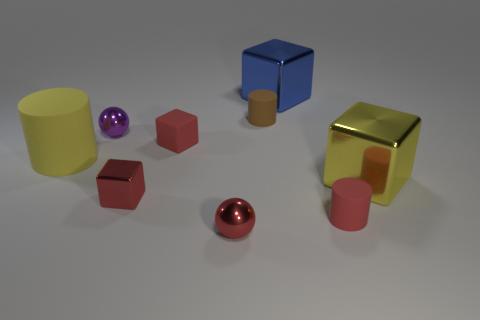Subtract 1 cubes. How many cubes are left? 3 Subtract all cyan cubes. Subtract all purple balls. How many cubes are left? 4 Add 1 tiny red metal cubes. How many objects exist? 10 Subtract all cubes. How many objects are left? 5 Subtract all spheres. Subtract all large blue shiny objects. How many objects are left? 6 Add 5 tiny cylinders. How many tiny cylinders are left? 7 Add 7 large yellow rubber cylinders. How many large yellow rubber cylinders exist? 8 Subtract 1 red balls. How many objects are left? 8 